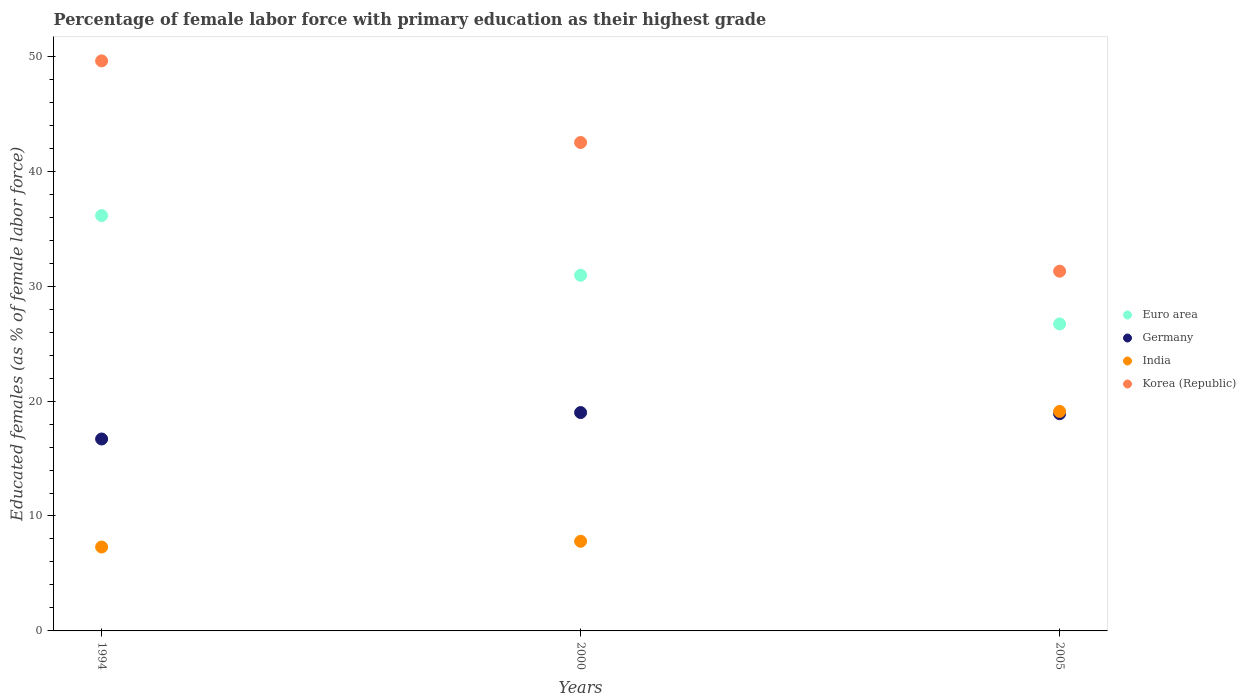Is the number of dotlines equal to the number of legend labels?
Give a very brief answer. Yes. What is the percentage of female labor force with primary education in Germany in 1994?
Give a very brief answer. 16.7. Across all years, what is the minimum percentage of female labor force with primary education in India?
Your answer should be compact. 7.3. In which year was the percentage of female labor force with primary education in Germany maximum?
Keep it short and to the point. 2000. In which year was the percentage of female labor force with primary education in India minimum?
Provide a succinct answer. 1994. What is the total percentage of female labor force with primary education in Euro area in the graph?
Your answer should be compact. 93.8. What is the difference between the percentage of female labor force with primary education in Germany in 2000 and that in 2005?
Provide a succinct answer. 0.1. What is the difference between the percentage of female labor force with primary education in India in 2005 and the percentage of female labor force with primary education in Korea (Republic) in 2000?
Keep it short and to the point. -23.4. What is the average percentage of female labor force with primary education in India per year?
Offer a very short reply. 11.4. In the year 2005, what is the difference between the percentage of female labor force with primary education in India and percentage of female labor force with primary education in Germany?
Give a very brief answer. 0.2. What is the ratio of the percentage of female labor force with primary education in Korea (Republic) in 1994 to that in 2005?
Provide a short and direct response. 1.58. Is the percentage of female labor force with primary education in Korea (Republic) in 2000 less than that in 2005?
Your answer should be very brief. No. What is the difference between the highest and the second highest percentage of female labor force with primary education in Euro area?
Provide a succinct answer. 5.19. What is the difference between the highest and the lowest percentage of female labor force with primary education in India?
Keep it short and to the point. 11.8. In how many years, is the percentage of female labor force with primary education in India greater than the average percentage of female labor force with primary education in India taken over all years?
Provide a succinct answer. 1. Is it the case that in every year, the sum of the percentage of female labor force with primary education in India and percentage of female labor force with primary education in Korea (Republic)  is greater than the percentage of female labor force with primary education in Euro area?
Provide a short and direct response. Yes. Is the percentage of female labor force with primary education in Germany strictly greater than the percentage of female labor force with primary education in India over the years?
Keep it short and to the point. No. How many years are there in the graph?
Make the answer very short. 3. What is the difference between two consecutive major ticks on the Y-axis?
Your answer should be very brief. 10. Are the values on the major ticks of Y-axis written in scientific E-notation?
Ensure brevity in your answer.  No. Does the graph contain any zero values?
Your answer should be very brief. No. Does the graph contain grids?
Give a very brief answer. No. What is the title of the graph?
Provide a short and direct response. Percentage of female labor force with primary education as their highest grade. Does "Belgium" appear as one of the legend labels in the graph?
Keep it short and to the point. No. What is the label or title of the Y-axis?
Offer a terse response. Educated females (as % of female labor force). What is the Educated females (as % of female labor force) in Euro area in 1994?
Your answer should be very brief. 36.14. What is the Educated females (as % of female labor force) in Germany in 1994?
Keep it short and to the point. 16.7. What is the Educated females (as % of female labor force) of India in 1994?
Ensure brevity in your answer.  7.3. What is the Educated females (as % of female labor force) in Korea (Republic) in 1994?
Give a very brief answer. 49.6. What is the Educated females (as % of female labor force) of Euro area in 2000?
Provide a succinct answer. 30.95. What is the Educated females (as % of female labor force) of Germany in 2000?
Make the answer very short. 19. What is the Educated females (as % of female labor force) in India in 2000?
Give a very brief answer. 7.8. What is the Educated females (as % of female labor force) of Korea (Republic) in 2000?
Offer a very short reply. 42.5. What is the Educated females (as % of female labor force) of Euro area in 2005?
Provide a short and direct response. 26.71. What is the Educated females (as % of female labor force) in Germany in 2005?
Provide a succinct answer. 18.9. What is the Educated females (as % of female labor force) in India in 2005?
Ensure brevity in your answer.  19.1. What is the Educated females (as % of female labor force) in Korea (Republic) in 2005?
Your answer should be very brief. 31.3. Across all years, what is the maximum Educated females (as % of female labor force) of Euro area?
Ensure brevity in your answer.  36.14. Across all years, what is the maximum Educated females (as % of female labor force) of Germany?
Keep it short and to the point. 19. Across all years, what is the maximum Educated females (as % of female labor force) in India?
Your answer should be compact. 19.1. Across all years, what is the maximum Educated females (as % of female labor force) in Korea (Republic)?
Offer a very short reply. 49.6. Across all years, what is the minimum Educated females (as % of female labor force) of Euro area?
Your answer should be very brief. 26.71. Across all years, what is the minimum Educated females (as % of female labor force) in Germany?
Your response must be concise. 16.7. Across all years, what is the minimum Educated females (as % of female labor force) of India?
Your answer should be very brief. 7.3. Across all years, what is the minimum Educated females (as % of female labor force) of Korea (Republic)?
Your answer should be compact. 31.3. What is the total Educated females (as % of female labor force) in Euro area in the graph?
Offer a terse response. 93.8. What is the total Educated females (as % of female labor force) in Germany in the graph?
Your answer should be very brief. 54.6. What is the total Educated females (as % of female labor force) in India in the graph?
Your answer should be compact. 34.2. What is the total Educated females (as % of female labor force) in Korea (Republic) in the graph?
Offer a terse response. 123.4. What is the difference between the Educated females (as % of female labor force) of Euro area in 1994 and that in 2000?
Give a very brief answer. 5.19. What is the difference between the Educated females (as % of female labor force) of Germany in 1994 and that in 2000?
Make the answer very short. -2.3. What is the difference between the Educated females (as % of female labor force) in India in 1994 and that in 2000?
Keep it short and to the point. -0.5. What is the difference between the Educated females (as % of female labor force) of Euro area in 1994 and that in 2005?
Provide a short and direct response. 9.43. What is the difference between the Educated females (as % of female labor force) in India in 1994 and that in 2005?
Make the answer very short. -11.8. What is the difference between the Educated females (as % of female labor force) of Korea (Republic) in 1994 and that in 2005?
Keep it short and to the point. 18.3. What is the difference between the Educated females (as % of female labor force) in Euro area in 2000 and that in 2005?
Offer a very short reply. 4.23. What is the difference between the Educated females (as % of female labor force) in Korea (Republic) in 2000 and that in 2005?
Give a very brief answer. 11.2. What is the difference between the Educated females (as % of female labor force) in Euro area in 1994 and the Educated females (as % of female labor force) in Germany in 2000?
Provide a short and direct response. 17.14. What is the difference between the Educated females (as % of female labor force) in Euro area in 1994 and the Educated females (as % of female labor force) in India in 2000?
Make the answer very short. 28.34. What is the difference between the Educated females (as % of female labor force) of Euro area in 1994 and the Educated females (as % of female labor force) of Korea (Republic) in 2000?
Ensure brevity in your answer.  -6.36. What is the difference between the Educated females (as % of female labor force) of Germany in 1994 and the Educated females (as % of female labor force) of Korea (Republic) in 2000?
Your response must be concise. -25.8. What is the difference between the Educated females (as % of female labor force) in India in 1994 and the Educated females (as % of female labor force) in Korea (Republic) in 2000?
Give a very brief answer. -35.2. What is the difference between the Educated females (as % of female labor force) in Euro area in 1994 and the Educated females (as % of female labor force) in Germany in 2005?
Offer a terse response. 17.24. What is the difference between the Educated females (as % of female labor force) in Euro area in 1994 and the Educated females (as % of female labor force) in India in 2005?
Provide a succinct answer. 17.04. What is the difference between the Educated females (as % of female labor force) of Euro area in 1994 and the Educated females (as % of female labor force) of Korea (Republic) in 2005?
Offer a very short reply. 4.84. What is the difference between the Educated females (as % of female labor force) in Germany in 1994 and the Educated females (as % of female labor force) in India in 2005?
Your response must be concise. -2.4. What is the difference between the Educated females (as % of female labor force) in Germany in 1994 and the Educated females (as % of female labor force) in Korea (Republic) in 2005?
Ensure brevity in your answer.  -14.6. What is the difference between the Educated females (as % of female labor force) in India in 1994 and the Educated females (as % of female labor force) in Korea (Republic) in 2005?
Make the answer very short. -24. What is the difference between the Educated females (as % of female labor force) of Euro area in 2000 and the Educated females (as % of female labor force) of Germany in 2005?
Keep it short and to the point. 12.05. What is the difference between the Educated females (as % of female labor force) of Euro area in 2000 and the Educated females (as % of female labor force) of India in 2005?
Your answer should be compact. 11.85. What is the difference between the Educated females (as % of female labor force) of Euro area in 2000 and the Educated females (as % of female labor force) of Korea (Republic) in 2005?
Your answer should be very brief. -0.35. What is the difference between the Educated females (as % of female labor force) in Germany in 2000 and the Educated females (as % of female labor force) in Korea (Republic) in 2005?
Provide a short and direct response. -12.3. What is the difference between the Educated females (as % of female labor force) in India in 2000 and the Educated females (as % of female labor force) in Korea (Republic) in 2005?
Your answer should be very brief. -23.5. What is the average Educated females (as % of female labor force) in Euro area per year?
Make the answer very short. 31.27. What is the average Educated females (as % of female labor force) of Germany per year?
Provide a short and direct response. 18.2. What is the average Educated females (as % of female labor force) of India per year?
Offer a terse response. 11.4. What is the average Educated females (as % of female labor force) in Korea (Republic) per year?
Your answer should be very brief. 41.13. In the year 1994, what is the difference between the Educated females (as % of female labor force) in Euro area and Educated females (as % of female labor force) in Germany?
Make the answer very short. 19.44. In the year 1994, what is the difference between the Educated females (as % of female labor force) of Euro area and Educated females (as % of female labor force) of India?
Your answer should be compact. 28.84. In the year 1994, what is the difference between the Educated females (as % of female labor force) of Euro area and Educated females (as % of female labor force) of Korea (Republic)?
Give a very brief answer. -13.46. In the year 1994, what is the difference between the Educated females (as % of female labor force) of Germany and Educated females (as % of female labor force) of India?
Offer a very short reply. 9.4. In the year 1994, what is the difference between the Educated females (as % of female labor force) of Germany and Educated females (as % of female labor force) of Korea (Republic)?
Your answer should be very brief. -32.9. In the year 1994, what is the difference between the Educated females (as % of female labor force) of India and Educated females (as % of female labor force) of Korea (Republic)?
Offer a very short reply. -42.3. In the year 2000, what is the difference between the Educated females (as % of female labor force) in Euro area and Educated females (as % of female labor force) in Germany?
Ensure brevity in your answer.  11.95. In the year 2000, what is the difference between the Educated females (as % of female labor force) in Euro area and Educated females (as % of female labor force) in India?
Your answer should be very brief. 23.15. In the year 2000, what is the difference between the Educated females (as % of female labor force) of Euro area and Educated females (as % of female labor force) of Korea (Republic)?
Offer a terse response. -11.55. In the year 2000, what is the difference between the Educated females (as % of female labor force) in Germany and Educated females (as % of female labor force) in Korea (Republic)?
Provide a short and direct response. -23.5. In the year 2000, what is the difference between the Educated females (as % of female labor force) in India and Educated females (as % of female labor force) in Korea (Republic)?
Your answer should be compact. -34.7. In the year 2005, what is the difference between the Educated females (as % of female labor force) of Euro area and Educated females (as % of female labor force) of Germany?
Give a very brief answer. 7.81. In the year 2005, what is the difference between the Educated females (as % of female labor force) in Euro area and Educated females (as % of female labor force) in India?
Keep it short and to the point. 7.61. In the year 2005, what is the difference between the Educated females (as % of female labor force) in Euro area and Educated females (as % of female labor force) in Korea (Republic)?
Your answer should be compact. -4.59. In the year 2005, what is the difference between the Educated females (as % of female labor force) in India and Educated females (as % of female labor force) in Korea (Republic)?
Offer a terse response. -12.2. What is the ratio of the Educated females (as % of female labor force) in Euro area in 1994 to that in 2000?
Provide a succinct answer. 1.17. What is the ratio of the Educated females (as % of female labor force) in Germany in 1994 to that in 2000?
Ensure brevity in your answer.  0.88. What is the ratio of the Educated females (as % of female labor force) in India in 1994 to that in 2000?
Offer a terse response. 0.94. What is the ratio of the Educated females (as % of female labor force) of Korea (Republic) in 1994 to that in 2000?
Keep it short and to the point. 1.17. What is the ratio of the Educated females (as % of female labor force) in Euro area in 1994 to that in 2005?
Your answer should be very brief. 1.35. What is the ratio of the Educated females (as % of female labor force) in Germany in 1994 to that in 2005?
Your answer should be very brief. 0.88. What is the ratio of the Educated females (as % of female labor force) in India in 1994 to that in 2005?
Offer a very short reply. 0.38. What is the ratio of the Educated females (as % of female labor force) of Korea (Republic) in 1994 to that in 2005?
Offer a terse response. 1.58. What is the ratio of the Educated females (as % of female labor force) of Euro area in 2000 to that in 2005?
Provide a short and direct response. 1.16. What is the ratio of the Educated females (as % of female labor force) of India in 2000 to that in 2005?
Provide a short and direct response. 0.41. What is the ratio of the Educated females (as % of female labor force) of Korea (Republic) in 2000 to that in 2005?
Provide a short and direct response. 1.36. What is the difference between the highest and the second highest Educated females (as % of female labor force) in Euro area?
Make the answer very short. 5.19. What is the difference between the highest and the second highest Educated females (as % of female labor force) in India?
Provide a succinct answer. 11.3. What is the difference between the highest and the second highest Educated females (as % of female labor force) of Korea (Republic)?
Your answer should be very brief. 7.1. What is the difference between the highest and the lowest Educated females (as % of female labor force) in Euro area?
Give a very brief answer. 9.43. What is the difference between the highest and the lowest Educated females (as % of female labor force) in Germany?
Your response must be concise. 2.3. What is the difference between the highest and the lowest Educated females (as % of female labor force) in India?
Provide a succinct answer. 11.8. What is the difference between the highest and the lowest Educated females (as % of female labor force) in Korea (Republic)?
Your answer should be compact. 18.3. 